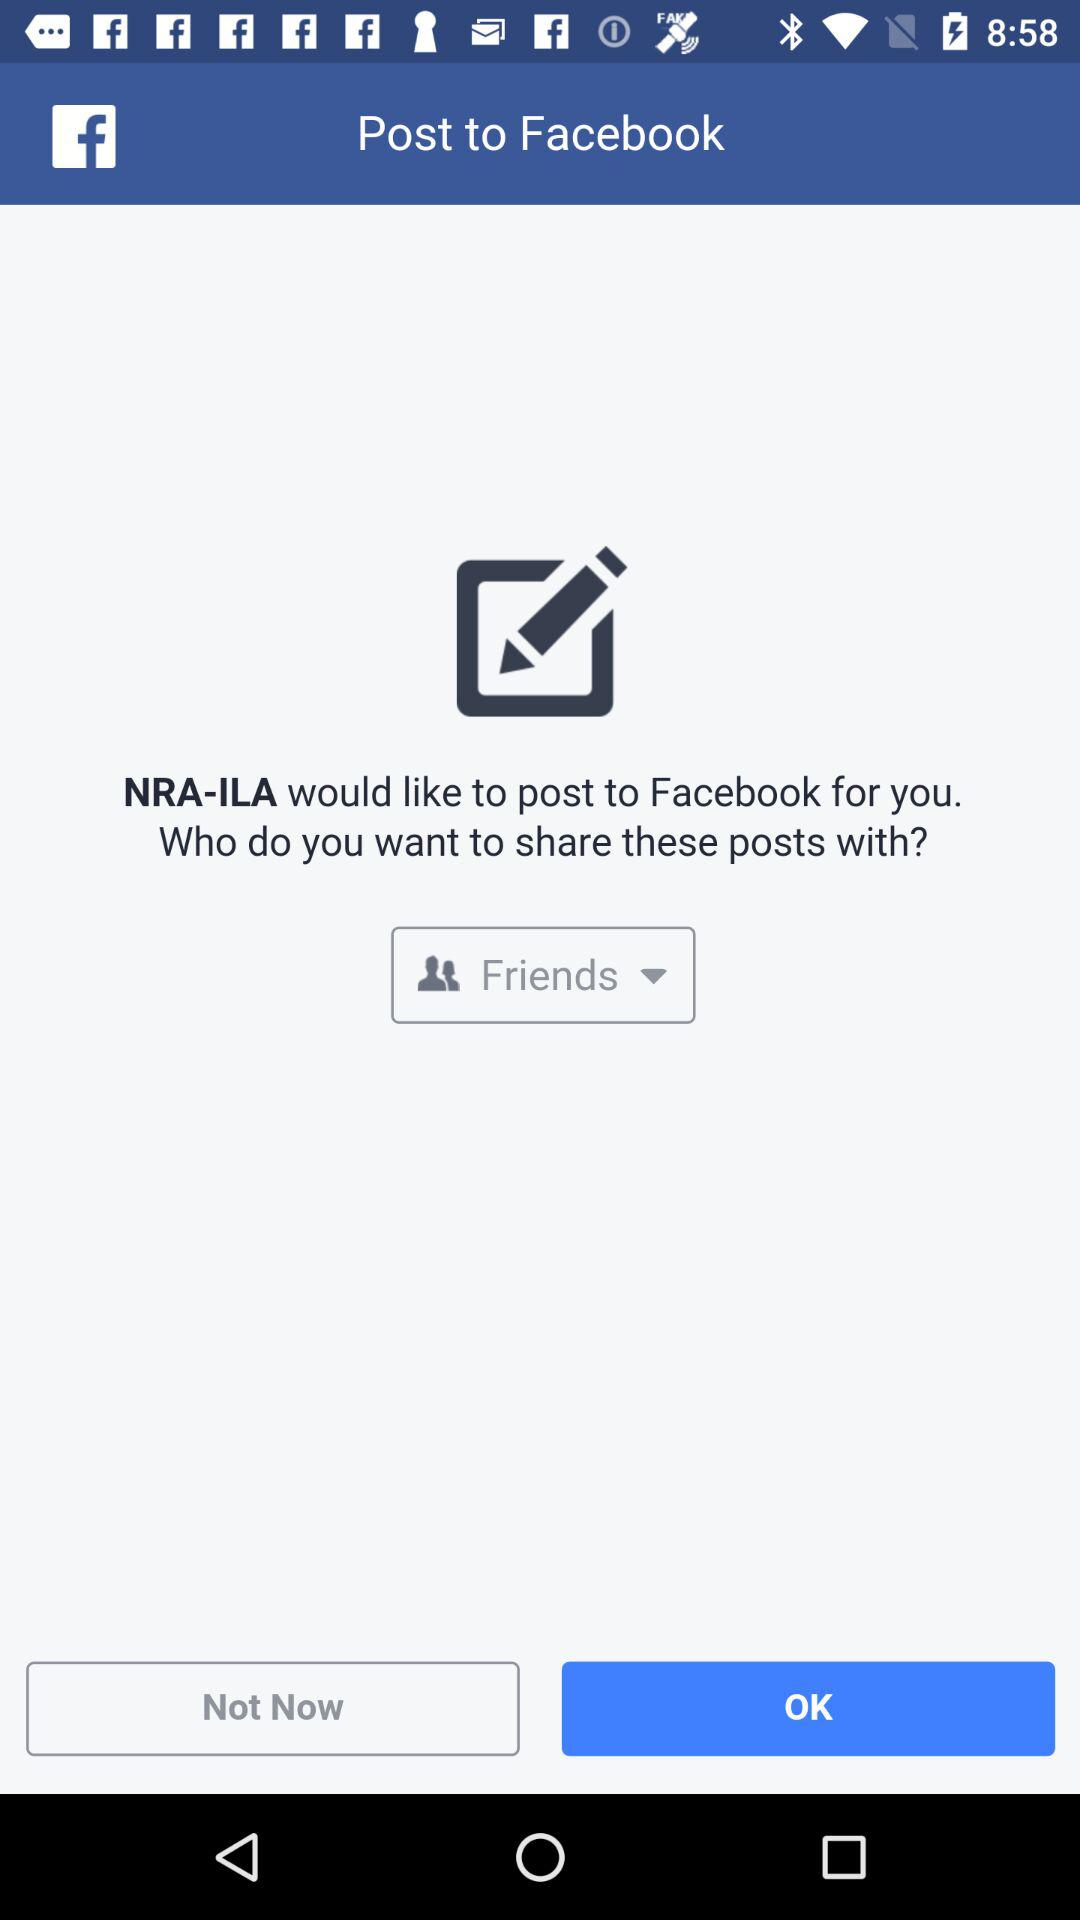What application would post to "Facebook"? The application "NRA-ILA" would post to "Facebook". 